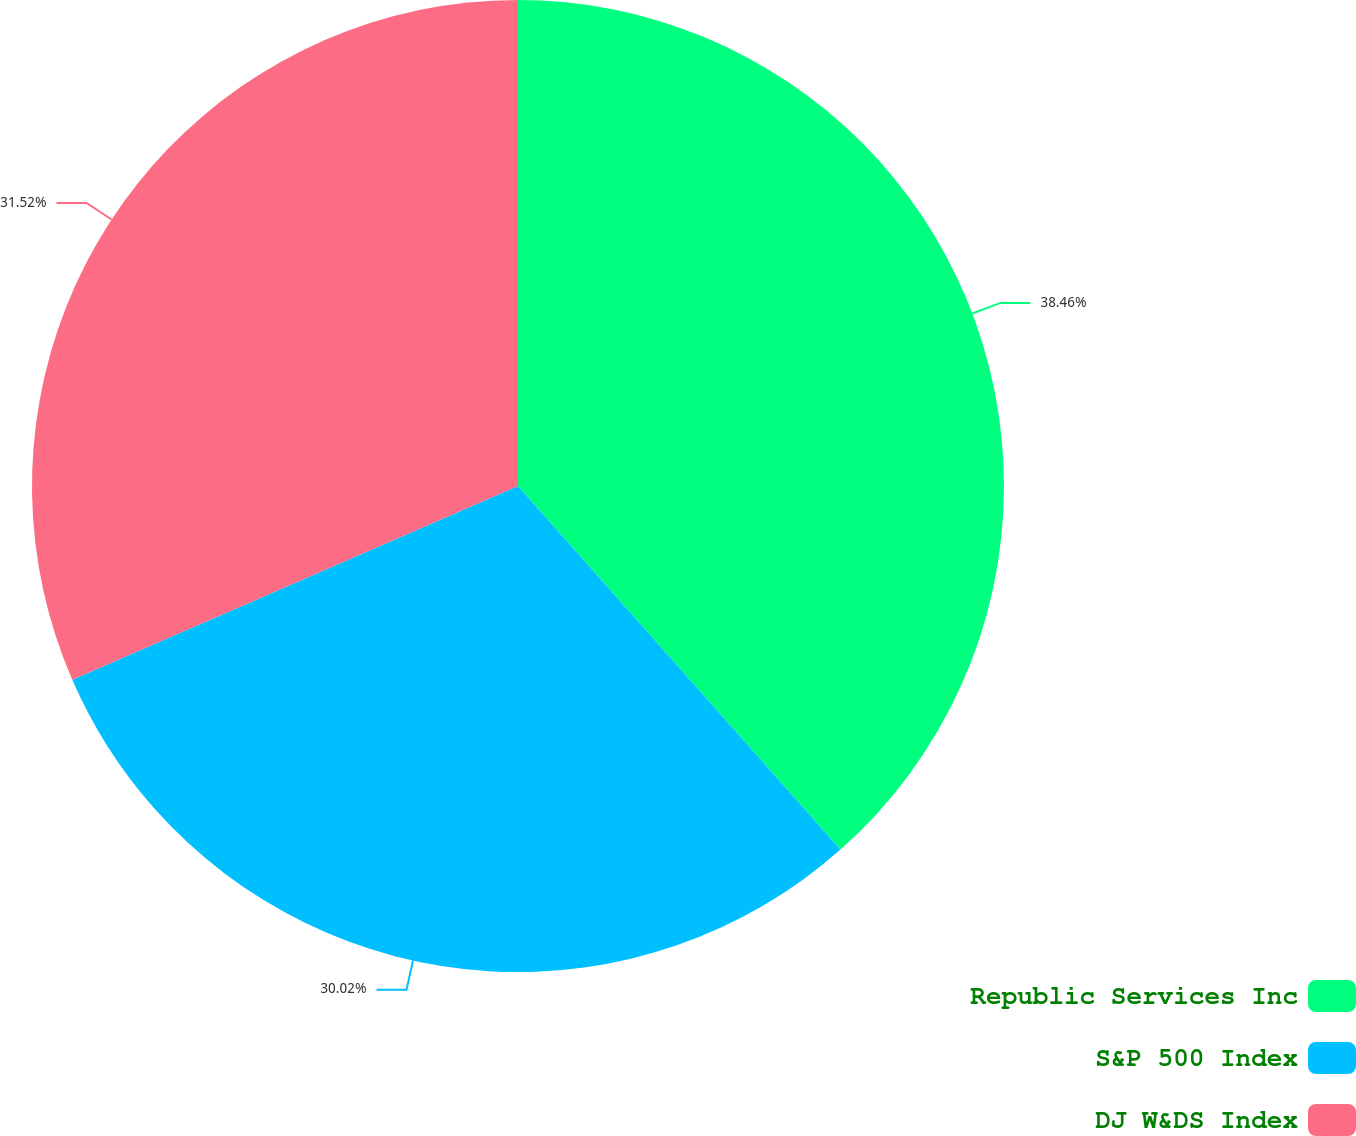Convert chart. <chart><loc_0><loc_0><loc_500><loc_500><pie_chart><fcel>Republic Services Inc<fcel>S&P 500 Index<fcel>DJ W&DS Index<nl><fcel>38.45%<fcel>30.02%<fcel>31.52%<nl></chart> 